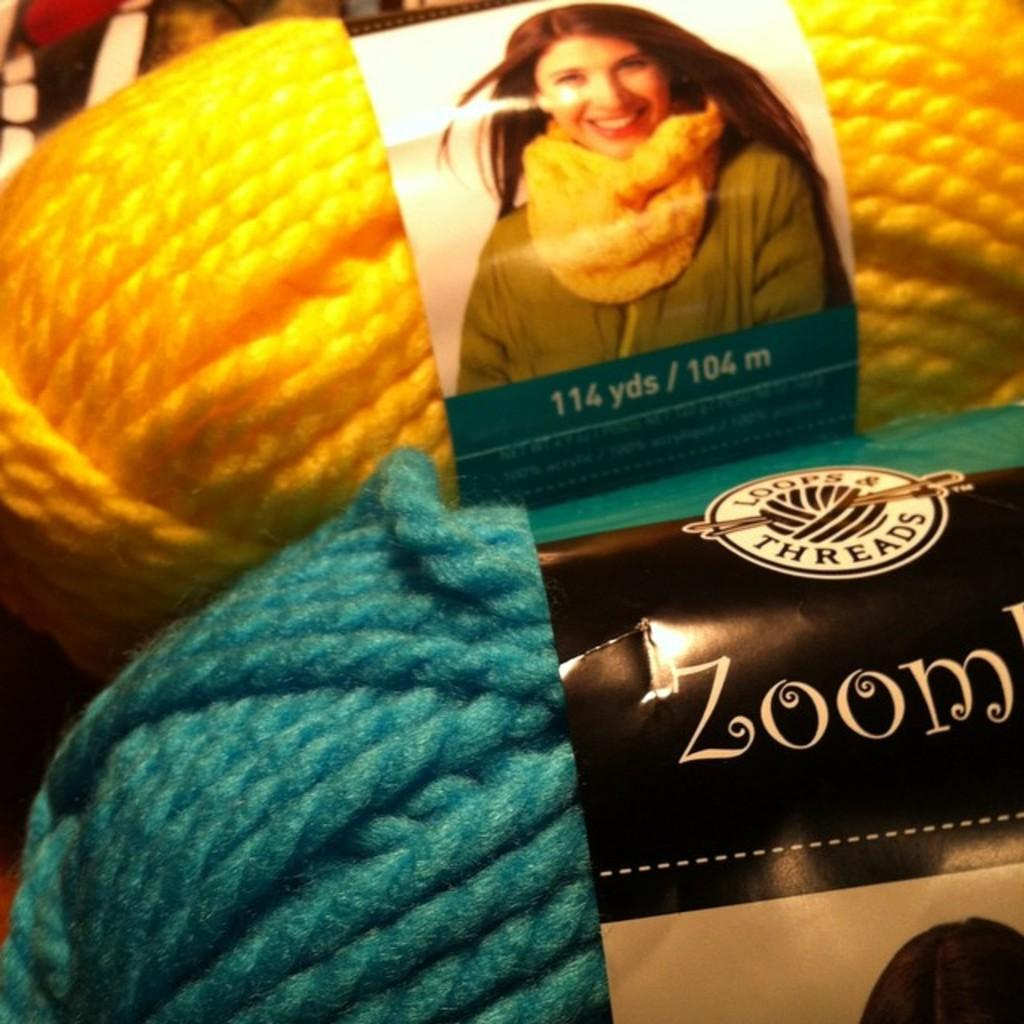What objects are present in the image? There are two woolen thread balls in the image. Can you describe the colors of the woolen thread balls? One woolen thread ball is orange in color, and the other is green in color. Are there any additional features on the woolen thread balls? Yes, there are two stickers attached to the woolen thread balls. What type of bell can be heard ringing in the image? There is no bell present in the image, and therefore no sound can be heard. 